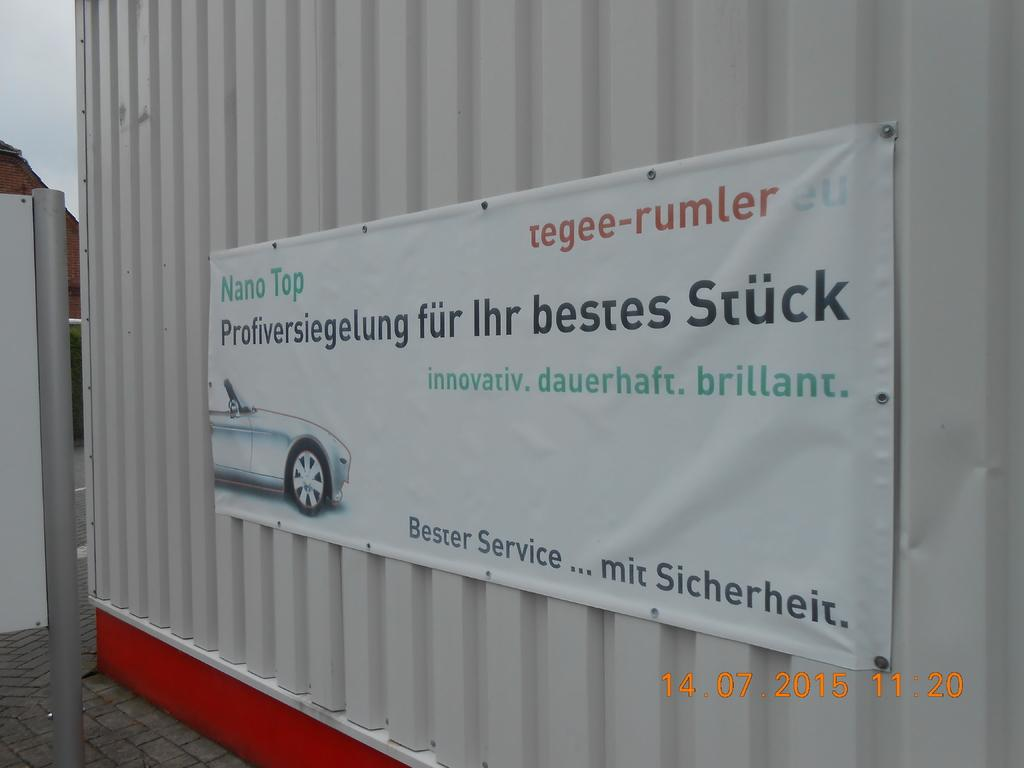What is the main subject in the center of the image? There is a poster in the center of the image. How is the poster positioned in the image? The poster is attached to a container. What can be seen in the background of the image? There is sky visible in the background of the image. What type of toothpaste is being used to hold the poster in the image? There is no toothpaste present in the image; the poster is attached to a container. What kind of pan is visible in the image? There is no pan present in the image. 